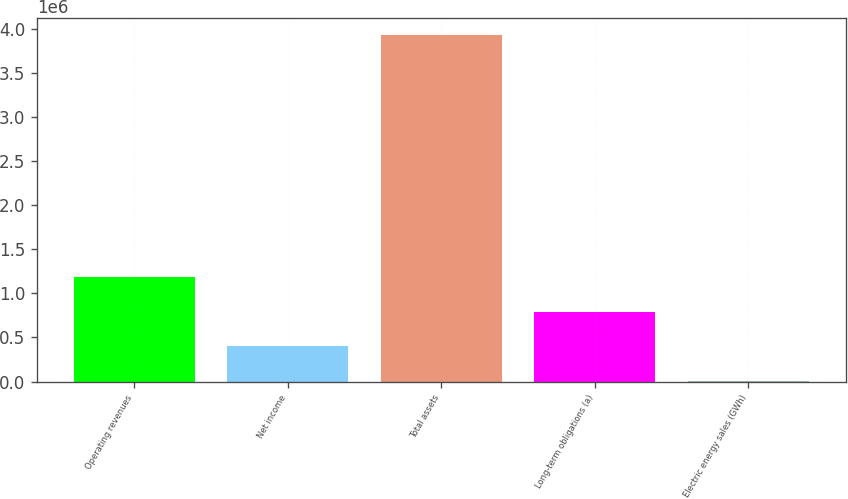Convert chart. <chart><loc_0><loc_0><loc_500><loc_500><bar_chart><fcel>Operating revenues<fcel>Net income<fcel>Total assets<fcel>Long-term obligations (a)<fcel>Electric energy sales (GWh)<nl><fcel>1.18208e+06<fcel>397617<fcel>3.92771e+06<fcel>789850<fcel>5384<nl></chart> 